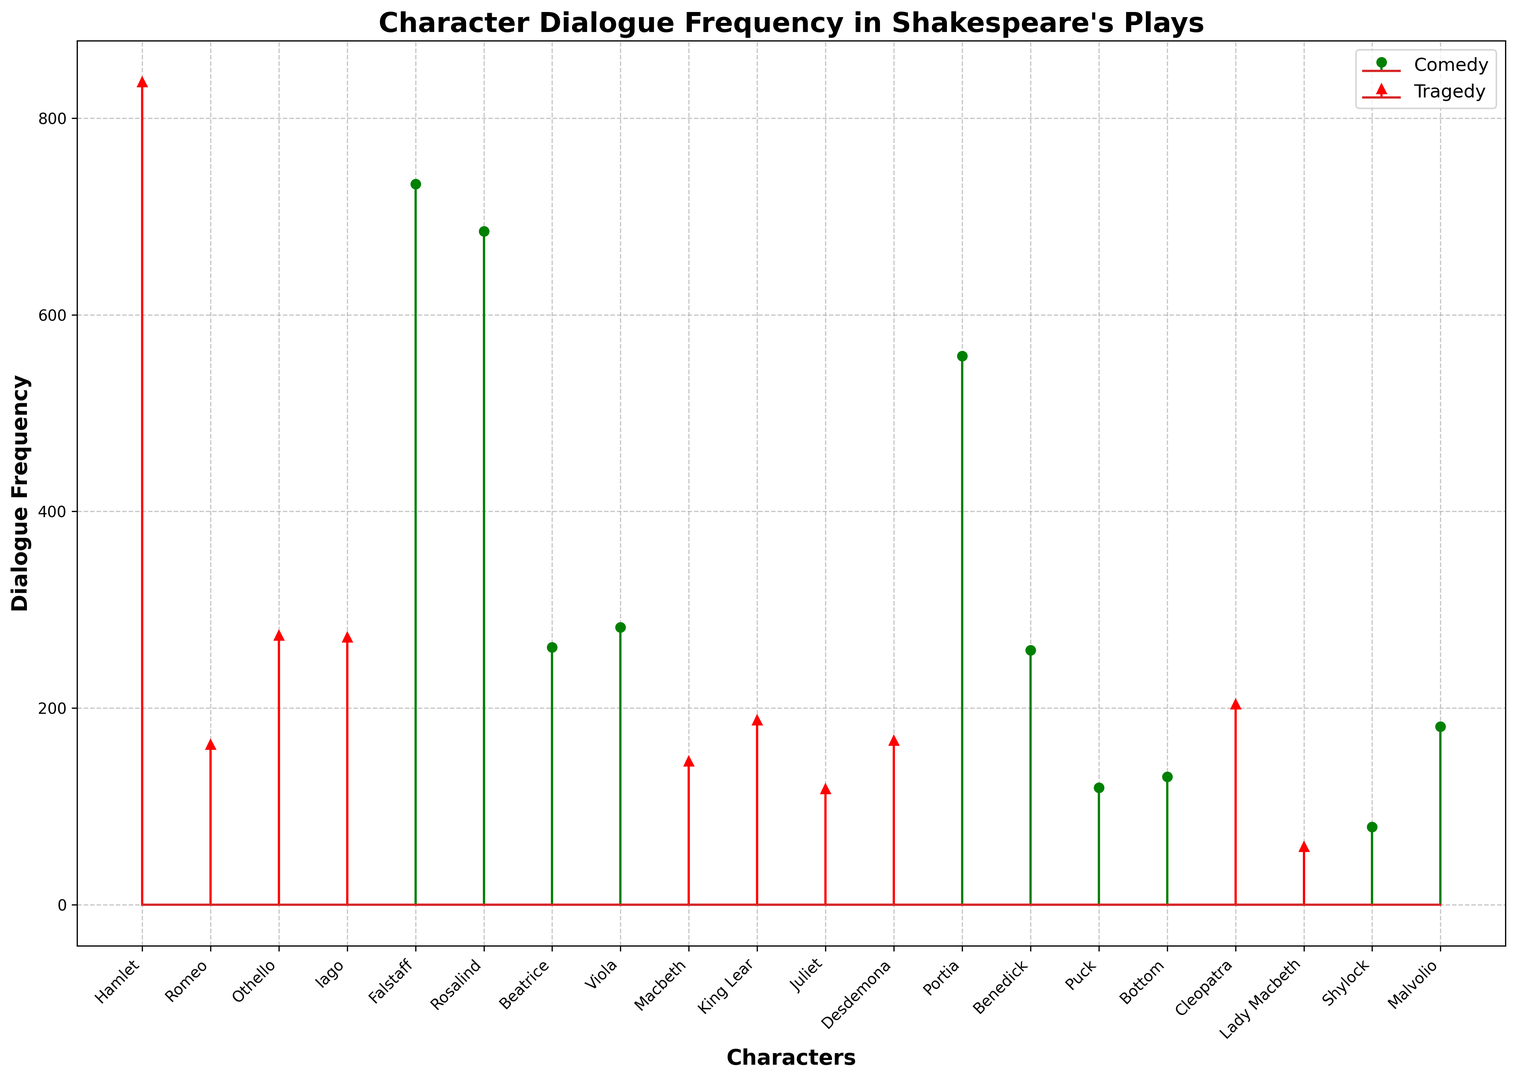Which character has the highest dialogue frequency in comedy? The green stems represent comedy characters. Identify the tallest green stem, which corresponds to the character with the highest dialogue frequency in comedy.
Answer: Falstaff How much more dialogue does Hamlet have compared to Romeo in tragedies? Hamlet and Romeo are both represented by red stems for tragedies. Look at the heights of the red stems for both characters and subtract Romeo's value from Hamlet's value. Hamlet has 837 dialogues and Romeo has 163. So, 837 - 163 = 674.
Answer: 674 What is the average dialogue frequency for the characters in comedies? Sum the dialogue frequencies of all comedy characters (733 + 685 + 262 + 282 + 558 + 259 + 119 + 130 + 79 + 181) and divide by the number of characters (10).
Answer: 329.8 Which play type shows a higher frequency of dialogue for Lady Macbeth? Compare the heights of the red and green stems for Lady Macbeth. Lady Macbeth has a red stem (tragedy) and no green stem (comedy), indicating she has dialogues in tragedies but not comedies.
Answer: Tragedy How does Desdemona's dialogue frequency in tragedies compare to Juliet's? Look at the red stems for Desdemona and Juliet. Desdemona's stem stands at 167, while Juliet's is at 118. Since 167 > 118, Desdemona has more dialogues than Juliet in tragedies.
Answer: Desdemona has more What is the sum of comedy dialogue frequencies for Rosalind and Viola? Identify the green stems for Rosalind and Viola. Rosalind has 685 and Viola has 282 dialogues. Add them together: 685 + 282 = 967.
Answer: 967 Which female character has the highest dialogue frequency in comedies? Identify the green stems and check the corresponding character names. Rosalind, Beatrice, Viola, and Portia are female characters. The highest among them is Rosalind with 685 dialogues.
Answer: Rosalind Is there any character who appears in both comedies and tragedies? Look for stems that appear in both green and red for the same character. None of the characters have both green and red stems, indicating no overlap.
Answer: No Compare the dialogue frequencies of Othello and Iago in tragedies. Look at the red stems for Othello and Iago. Both have similar heights: Othello has 274 and Iago has 272. Since their values are close, they have almost equal dialogue frequencies.
Answer: Almost equal What is the total dialogue frequency for all characters in tragedies? Sum all the dialogue frequencies for characters with red stems (837 + 163 + 274 + 272 + 146 + 188 + 118 + 167 + 204 + 59).
Answer: 2428 